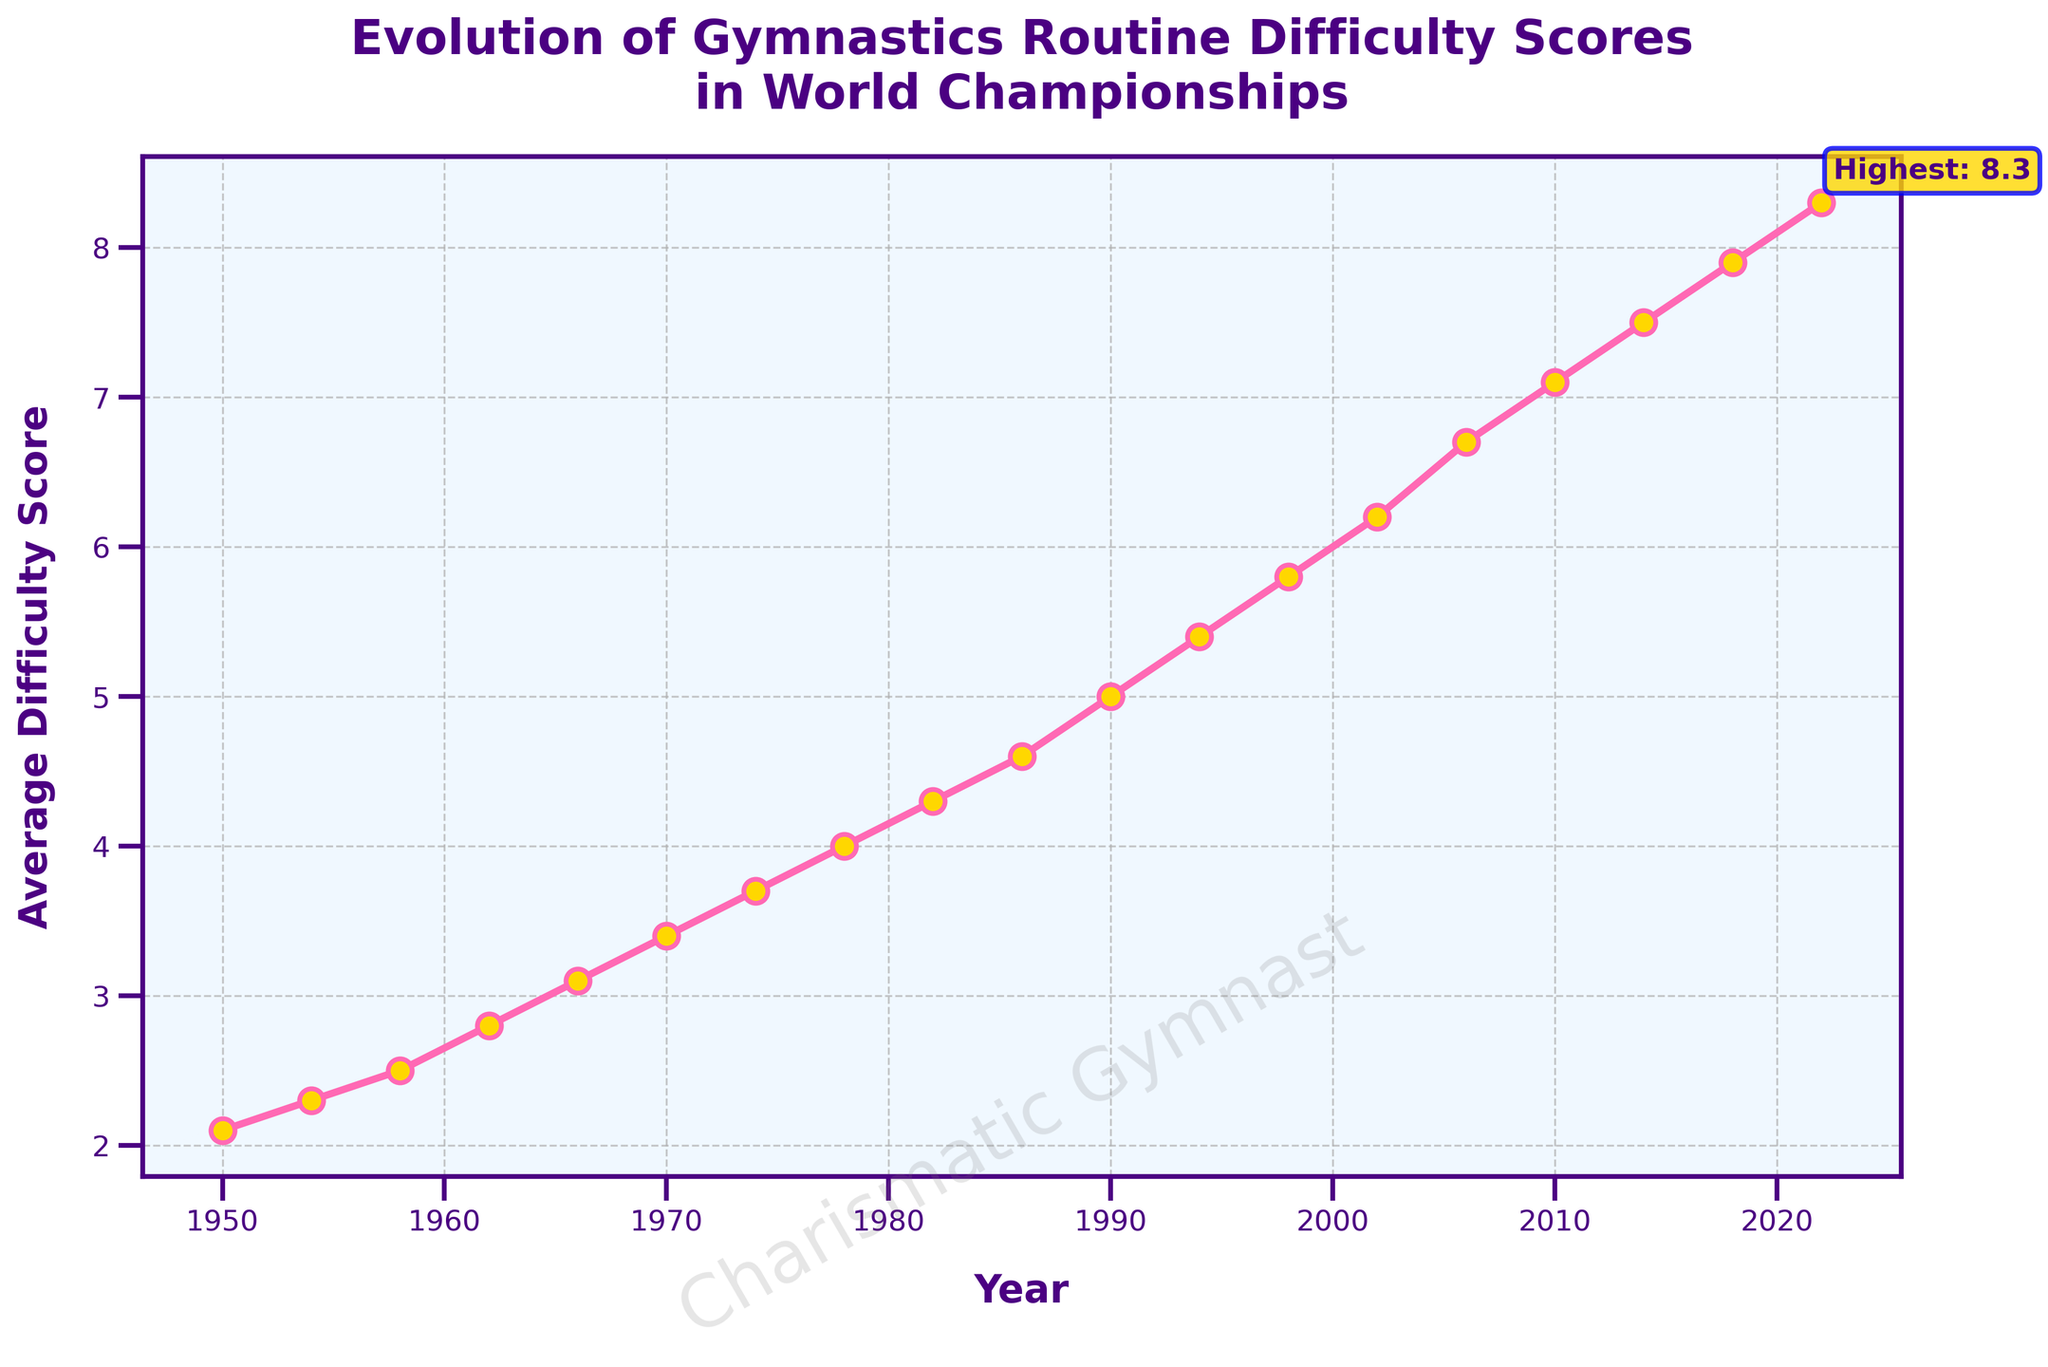What year saw the highest recorded average difficulty score? The highest recorded average difficulty score on the plot is 8.3, and it occurred in the year 2022.
Answer: 2022 How did the average difficulty score change between 1990 and 1994? The average difficulty score increased from 5.0 in 1990 to 5.4 in 1994.
Answer: It increased by 0.4 Which year showed the most significant increase in average difficulty score compared to the previous recorded year? The most significant increase can be determined by looking at the differences between consecutive data points. The increase from 2002 to 2006 (6.2 to 6.7) is 0.5, which is the largest increase.
Answer: 2006 What is the general trend of the average difficulty scores over the years? Observing the line plot, the average difficulty scores have consistently increased from 1950 to 2022.
Answer: It has increased What was the average difficulty score in 1966 relative to 1958? The average difficulty score in 1966 was 3.1, and in 1958 it was 2.5, so relative to 1958, the score in 1966 increased by 0.6.
Answer: Increased by 0.6 Which decade saw the fastest growth in average difficulty score? To determine the fastest growth, compare the scores at the start and end of each decade. The decade from 2000 to 2010 went from 6.2 to 7.1, a change of 0.9, which is the fastest growth.
Answer: 2000-2010 How does the average difficulty score in 2018 compare to that in 2010? The average difficulty score in 2018 is 7.9, whereas in 2010, it was 7.1. Therefore, the score in 2018 is higher by 0.8.
Answer: Higher by 0.8 Between which consecutive World Championships did the average difficulty score first reach 4.0? The plot shows the average difficulty score reaching 4.0 between the 1974 (3.7) and 1978 (4.0) World Championships.
Answer: Between 1974 and 1978 What can you say about the trend between 1950 and 1962? From 1950 to 1962, the average difficulty score shows a steady increase from 2.1 to 2.8.
Answer: It steadily increased Is there any year where the average difficulty score remained constant as compared to the previous recorded year? By observing the plot, there isn't any year where the average difficulty score remained constant; it always shows an increase.
Answer: No 